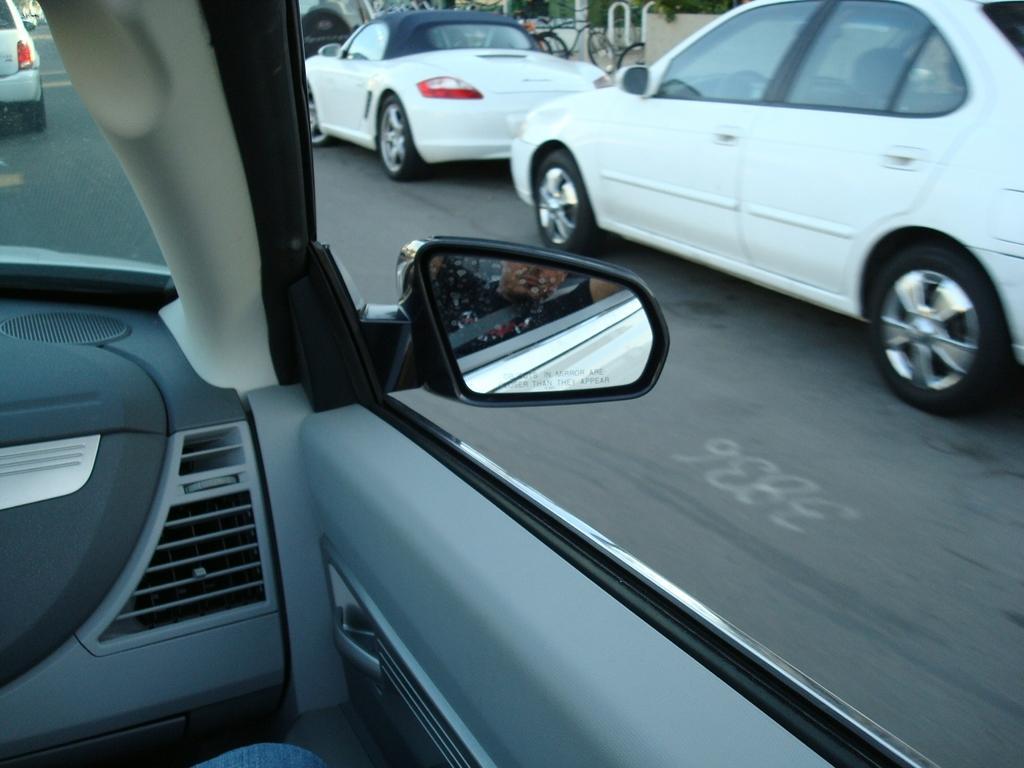In one or two sentences, can you explain what this image depicts? This is a view from the car, in this image there are a few cars parked on the road surface, in front of the image there is a side mirror of a car. 